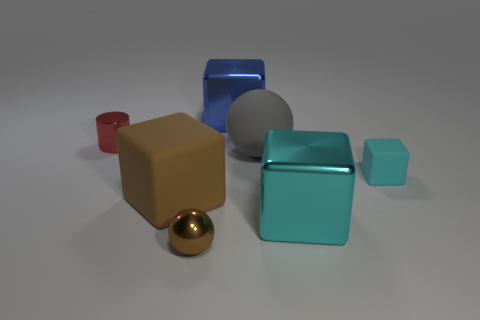What shape is the other metallic thing that is the same size as the red thing?
Provide a succinct answer. Sphere. Is there a small gray metallic thing that has the same shape as the cyan metallic thing?
Make the answer very short. No. There is a metallic thing behind the tiny thing behind the big gray matte thing; what shape is it?
Keep it short and to the point. Cube. The large cyan shiny thing is what shape?
Ensure brevity in your answer.  Cube. What material is the cyan object that is in front of the thing that is on the right side of the large metal block that is in front of the gray rubber object made of?
Make the answer very short. Metal. What number of other things are there of the same material as the small cyan thing
Your answer should be compact. 2. There is a metal block that is in front of the brown block; what number of small metallic things are behind it?
Provide a succinct answer. 1. What number of cylinders are small red metallic things or brown matte objects?
Give a very brief answer. 1. What color is the object that is on the left side of the blue object and behind the large gray rubber sphere?
Provide a short and direct response. Red. Are there any other things that have the same color as the small sphere?
Make the answer very short. Yes. 